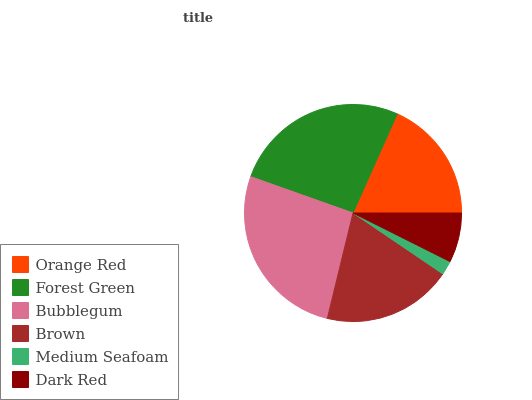Is Medium Seafoam the minimum?
Answer yes or no. Yes. Is Bubblegum the maximum?
Answer yes or no. Yes. Is Forest Green the minimum?
Answer yes or no. No. Is Forest Green the maximum?
Answer yes or no. No. Is Forest Green greater than Orange Red?
Answer yes or no. Yes. Is Orange Red less than Forest Green?
Answer yes or no. Yes. Is Orange Red greater than Forest Green?
Answer yes or no. No. Is Forest Green less than Orange Red?
Answer yes or no. No. Is Brown the high median?
Answer yes or no. Yes. Is Orange Red the low median?
Answer yes or no. Yes. Is Medium Seafoam the high median?
Answer yes or no. No. Is Brown the low median?
Answer yes or no. No. 